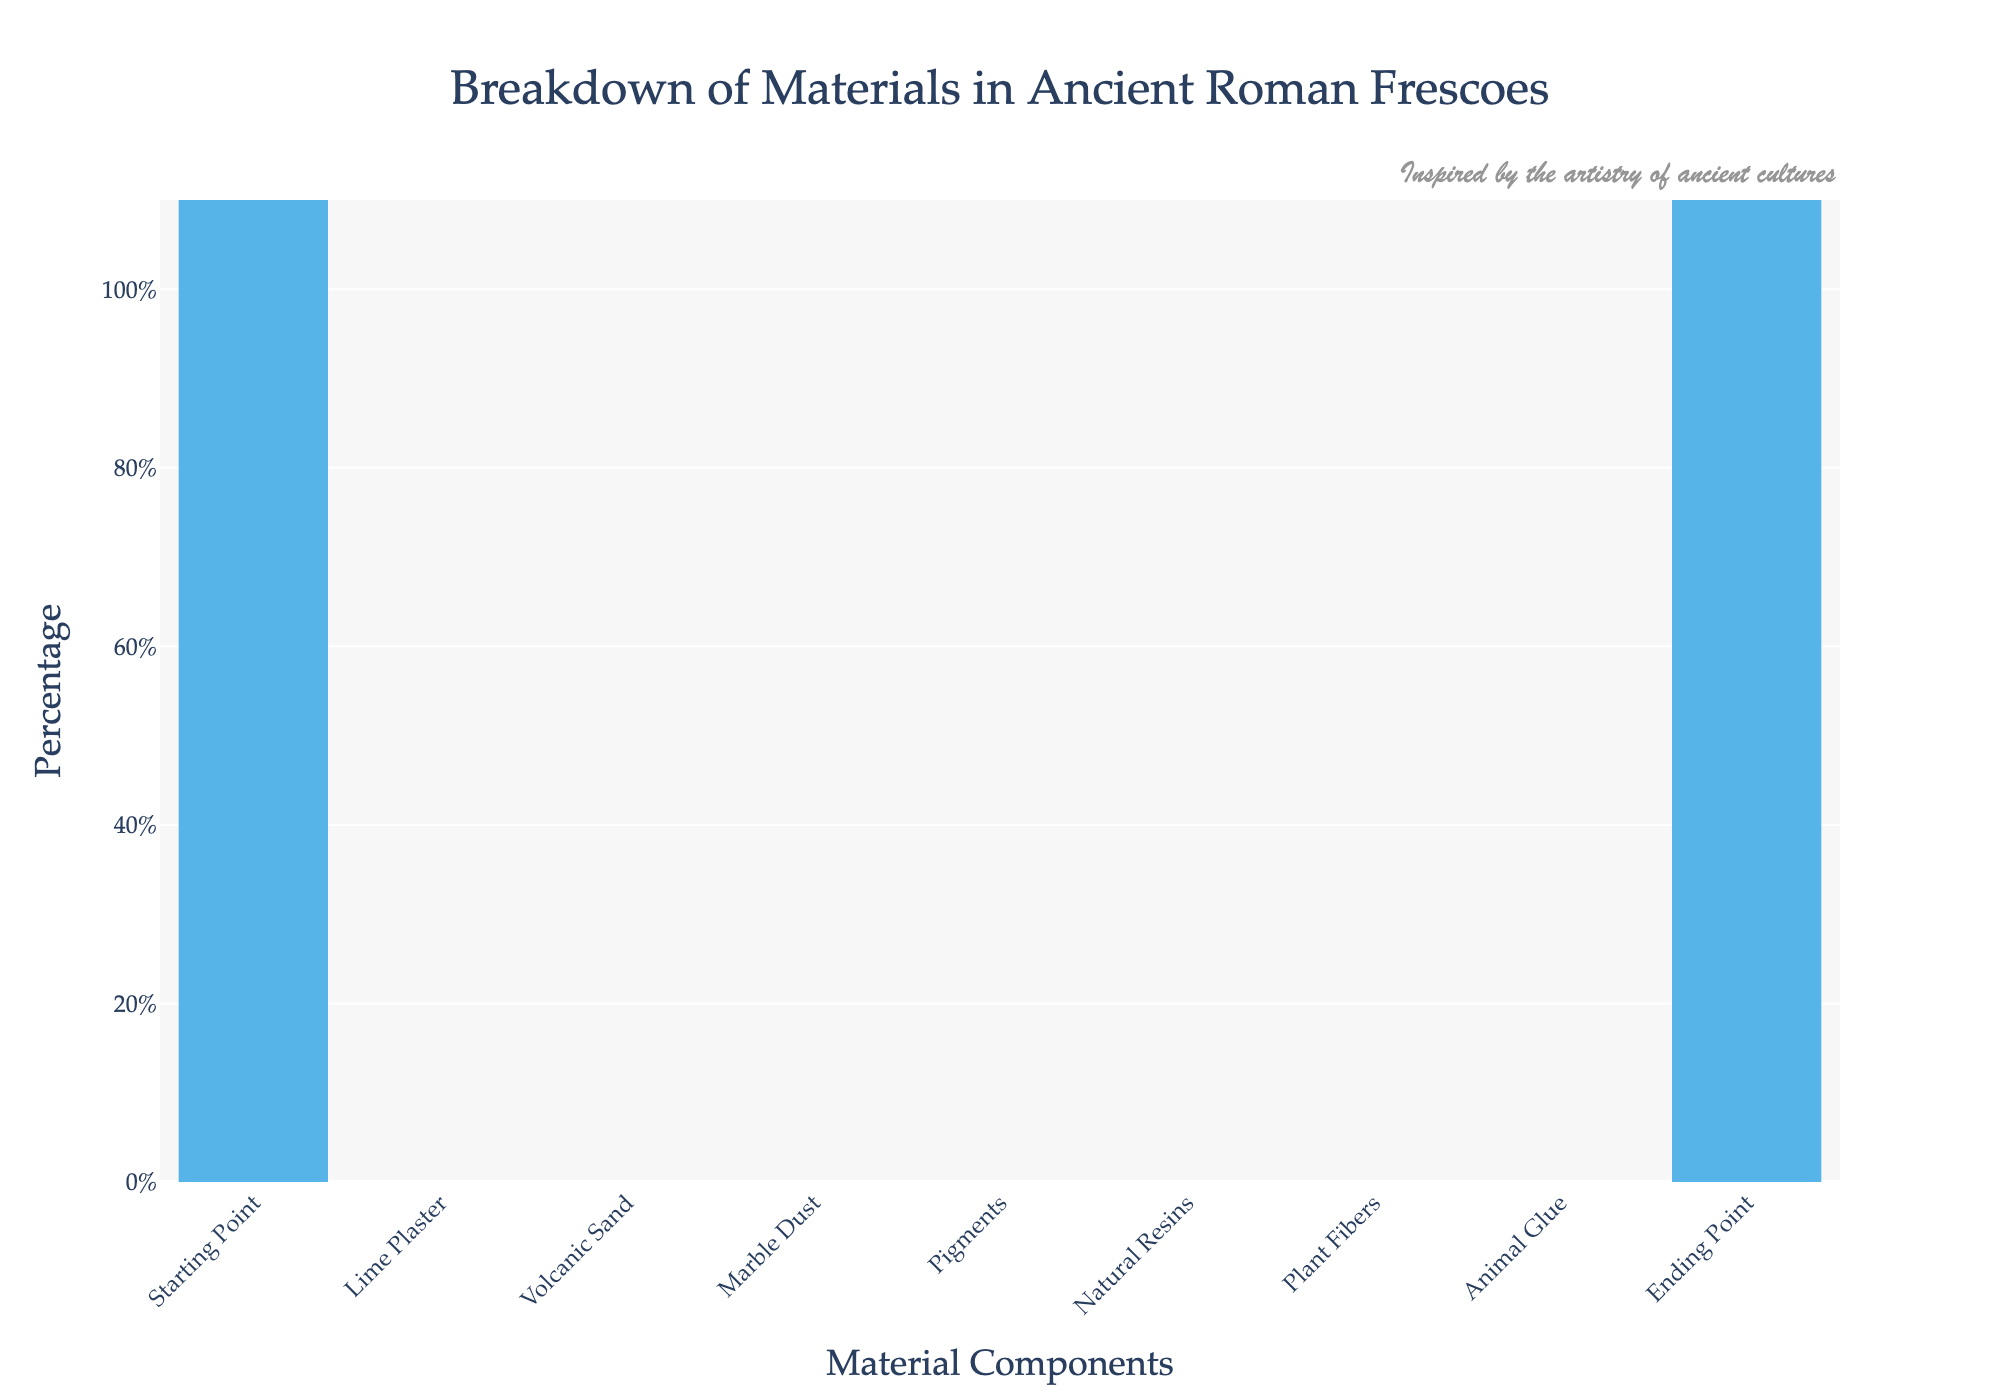what is the title of the chart? The title of the chart is typically positioned at the top center. It reads "Breakdown of Materials in Ancient Roman Frescoes".
Answer: Breakdown of Materials in Ancient Roman Frescoes What percentage of lime plaster is used? The percentage of lime plaster used is displayed on the bar representing lime plaster, which shows a decrease from the starting point. The text on this bar indicates it is -35%.
Answer: -35% Which material has the smallest contribution by percentage? By observing the waterfall chart, the material with the smallest bar, indicating its smallest contribution, is animal glue. The text on the bar confirms this value as -3%.
Answer: -3% How much percentage in total do the pigments, natural resins, and plant fibers contribute? To find the total contribution of pigments, natural resins, and plant fibers, sum up their individual contributions: -12% (pigments) + -8% (natural resins) + -5% (plant fibers) = -25%.
Answer: -25% What percentage does the ending point indicate? The ending point is typically highlighted differently in waterfall charts. The marker for "Ending Point" has a value of 2%.
Answer: 2% Which material shows a 20% reduction in use? By examining the segments representing the materials, the one indicating a -20% reduction is volcanic sand.
Answer: Volcanic Sand Compare the contributions of marble dust and plant fibers. Which one is greater and by how much? Marble dust has a contribution of -15%, while plant fibers have -5%. The difference between them is 15% - 5% = 10%. Marble dust's contribution is 10% greater than plant fibers.
Answer: Marble dust by 10% What overall trend can you observe from the materials presented? Observing the waterfall chart, most materials are shown with negative values, indicating a reduction in the overall percentage from the starting point to the ending point, suggesting that materials were progressively subtracted.
Answer: Gradual reduction How does the contribution of animal glue compare to the ending point percentage? The contribution of animal glue is -3%, and the ending point shows a value of 2%. These values show that animal glue's contribution is less by 3% compared to the ending point which is positive.
Answer: Less by 3% 